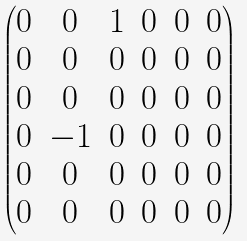<formula> <loc_0><loc_0><loc_500><loc_500>\begin{pmatrix} 0 & 0 & 1 & 0 & 0 & 0 \\ 0 & 0 & 0 & 0 & 0 & 0 \\ 0 & 0 & 0 & 0 & 0 & 0 \\ 0 & - 1 & 0 & 0 & 0 & 0 \\ 0 & 0 & 0 & 0 & 0 & 0 \\ 0 & 0 & 0 & 0 & 0 & 0 \\ \end{pmatrix}</formula> 